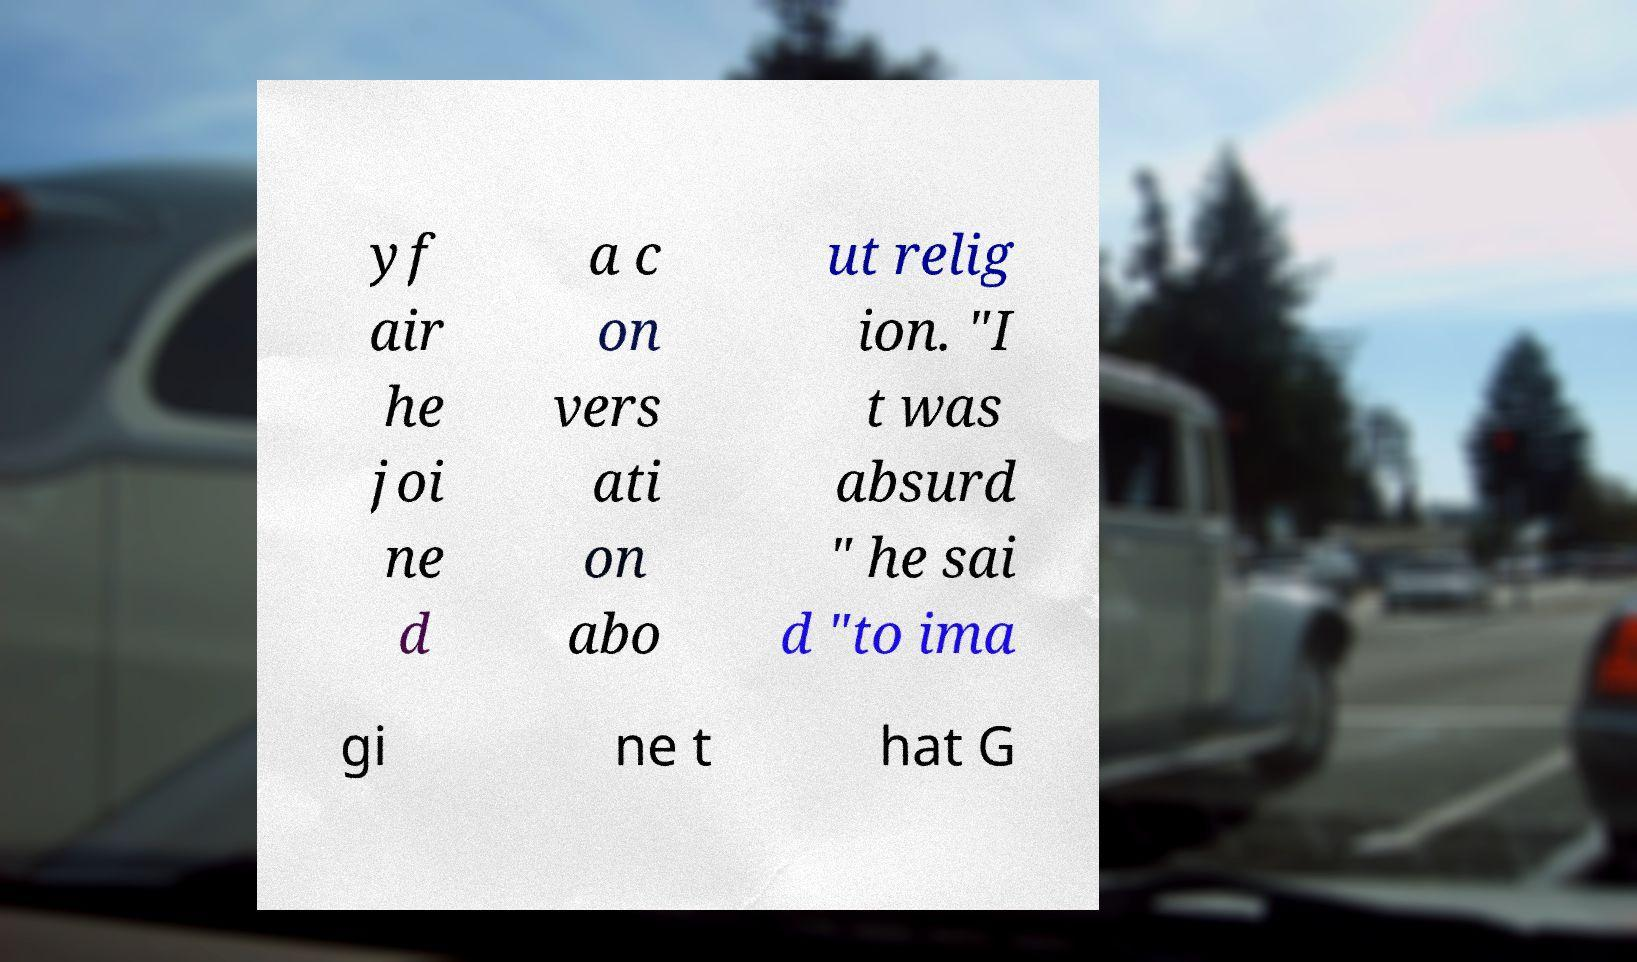Can you accurately transcribe the text from the provided image for me? yf air he joi ne d a c on vers ati on abo ut relig ion. "I t was absurd " he sai d "to ima gi ne t hat G 